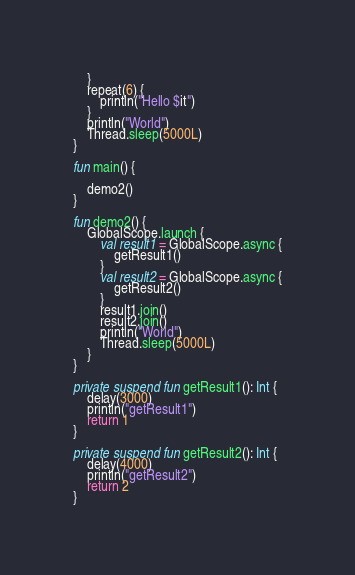<code> <loc_0><loc_0><loc_500><loc_500><_Kotlin_>    }
    repeat(6) {
        println("Hello $it")
    }
    println("World")
    Thread.sleep(5000L)
}

fun main() {

    demo2()
}

fun demo2() {
    GlobalScope.launch {
        val result1 = GlobalScope.async {
            getResult1()
        }
        val result2 = GlobalScope.async {
            getResult2()
        }
        result1.join()
        result2.join()
        println("World")
        Thread.sleep(5000L)
    }
}

private suspend fun getResult1(): Int {
    delay(3000)
    println("getResult1")
    return 1
}

private suspend fun getResult2(): Int {
    delay(4000)
    println("getResult2")
    return 2
}</code> 